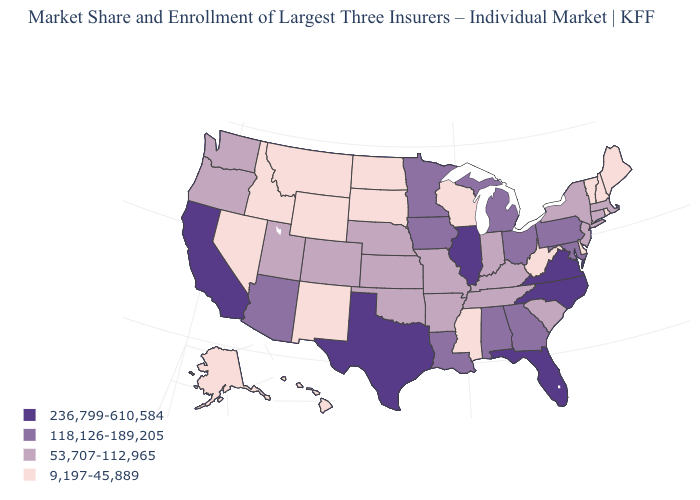Does West Virginia have a lower value than Maine?
Keep it brief. No. Name the states that have a value in the range 236,799-610,584?
Give a very brief answer. California, Florida, Illinois, North Carolina, Texas, Virginia. What is the value of California?
Be succinct. 236,799-610,584. Among the states that border New Hampshire , does Maine have the lowest value?
Answer briefly. Yes. Does the map have missing data?
Answer briefly. No. How many symbols are there in the legend?
Quick response, please. 4. Among the states that border Kentucky , which have the highest value?
Be succinct. Illinois, Virginia. Does Connecticut have the same value as Vermont?
Quick response, please. No. What is the highest value in the West ?
Write a very short answer. 236,799-610,584. Name the states that have a value in the range 9,197-45,889?
Concise answer only. Alaska, Delaware, Hawaii, Idaho, Maine, Mississippi, Montana, Nevada, New Hampshire, New Mexico, North Dakota, Rhode Island, South Dakota, Vermont, West Virginia, Wisconsin, Wyoming. Name the states that have a value in the range 118,126-189,205?
Give a very brief answer. Alabama, Arizona, Georgia, Iowa, Louisiana, Maryland, Michigan, Minnesota, Ohio, Pennsylvania. Among the states that border Colorado , which have the lowest value?
Give a very brief answer. New Mexico, Wyoming. Which states have the lowest value in the Northeast?
Give a very brief answer. Maine, New Hampshire, Rhode Island, Vermont. What is the value of Rhode Island?
Write a very short answer. 9,197-45,889. What is the value of Alaska?
Answer briefly. 9,197-45,889. 